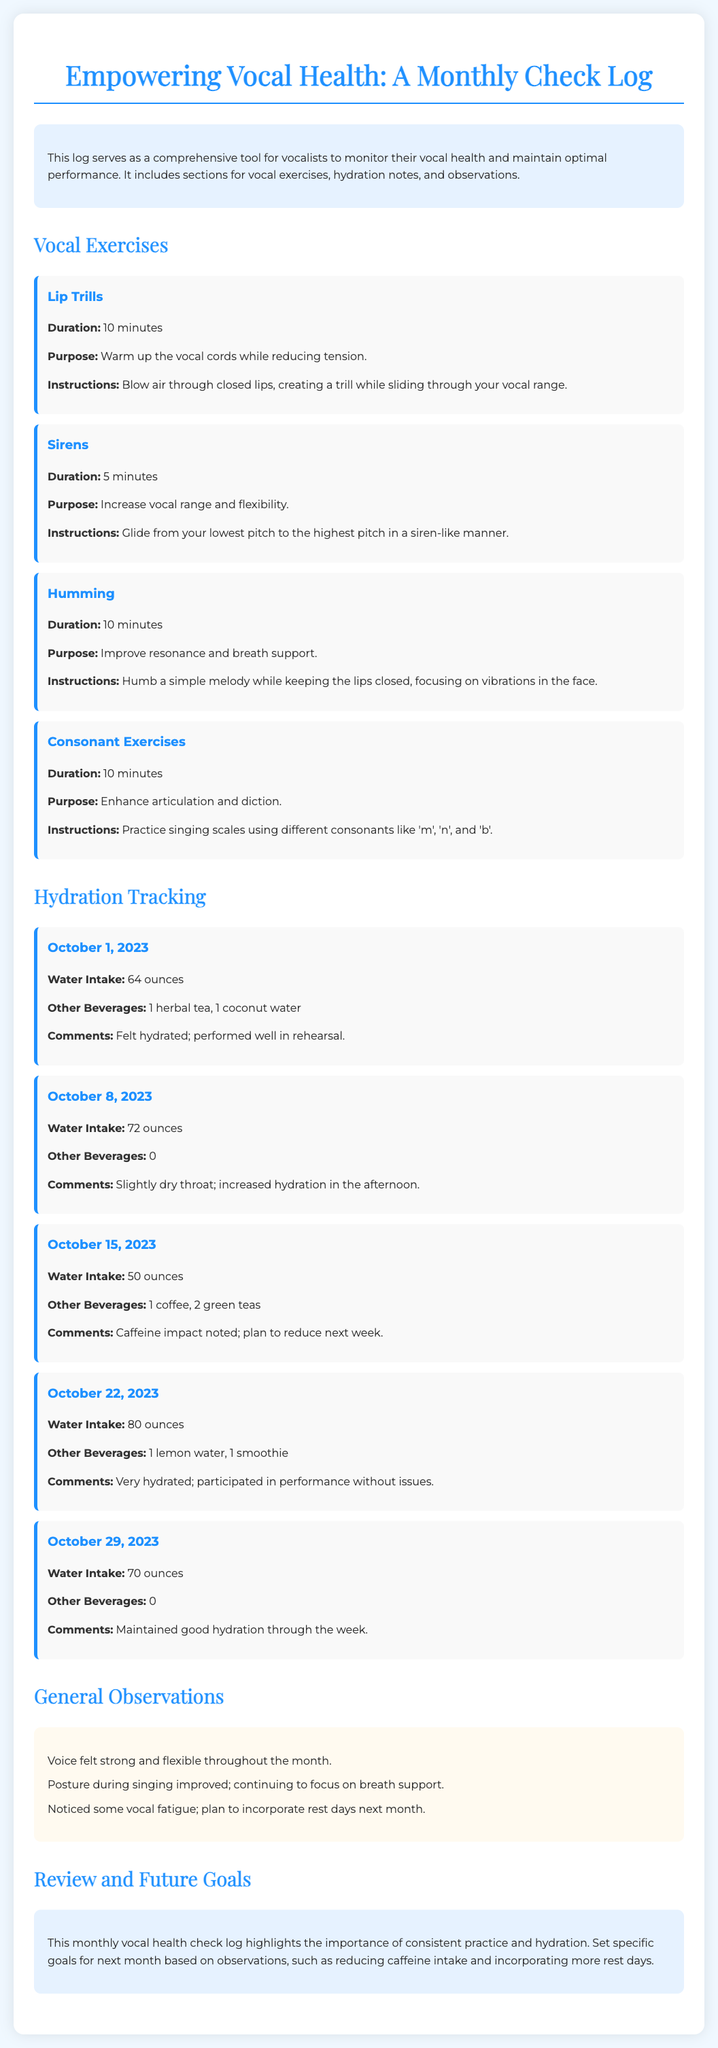What is the title of the document? The title of the document is prominently displayed at the top and provides the main subject of the content.
Answer: Empowering Vocal Health: A Monthly Check Log How long should lip trills be practiced? The duration for practicing lip trills is specified under the exercise section for that particular exercise.
Answer: 10 minutes On which date was the water intake 50 ounces? The specific hydration entry provides the date alongside the water intake amount for clear reference.
Answer: October 15, 2023 What is the purpose of humming? The purpose is detailed in the exercise section and explains the benefits of that particular vocal exercise.
Answer: Improve resonance and breath support How many ounces of water were consumed on October 22, 2023? The entry for that date lists the total water intake clearly alongside other beverages.
Answer: 80 ounces What did the observations note about vocal fatigue? The observations section summarizes overall vocal health and mentions any noteworthy points.
Answer: Noticed some vocal fatigue What are the set future goals mentioned in the conclusion? The conclusion section outlines specific action items based on the previous month's observations to improve vocal health.
Answer: Reducing caffeine intake and incorporating more rest days 